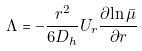<formula> <loc_0><loc_0><loc_500><loc_500>\Lambda = - \frac { r ^ { 2 } } { 6 D _ { h } } U _ { r } \frac { \partial { \ln \bar { \mu } } } { \partial r }</formula> 